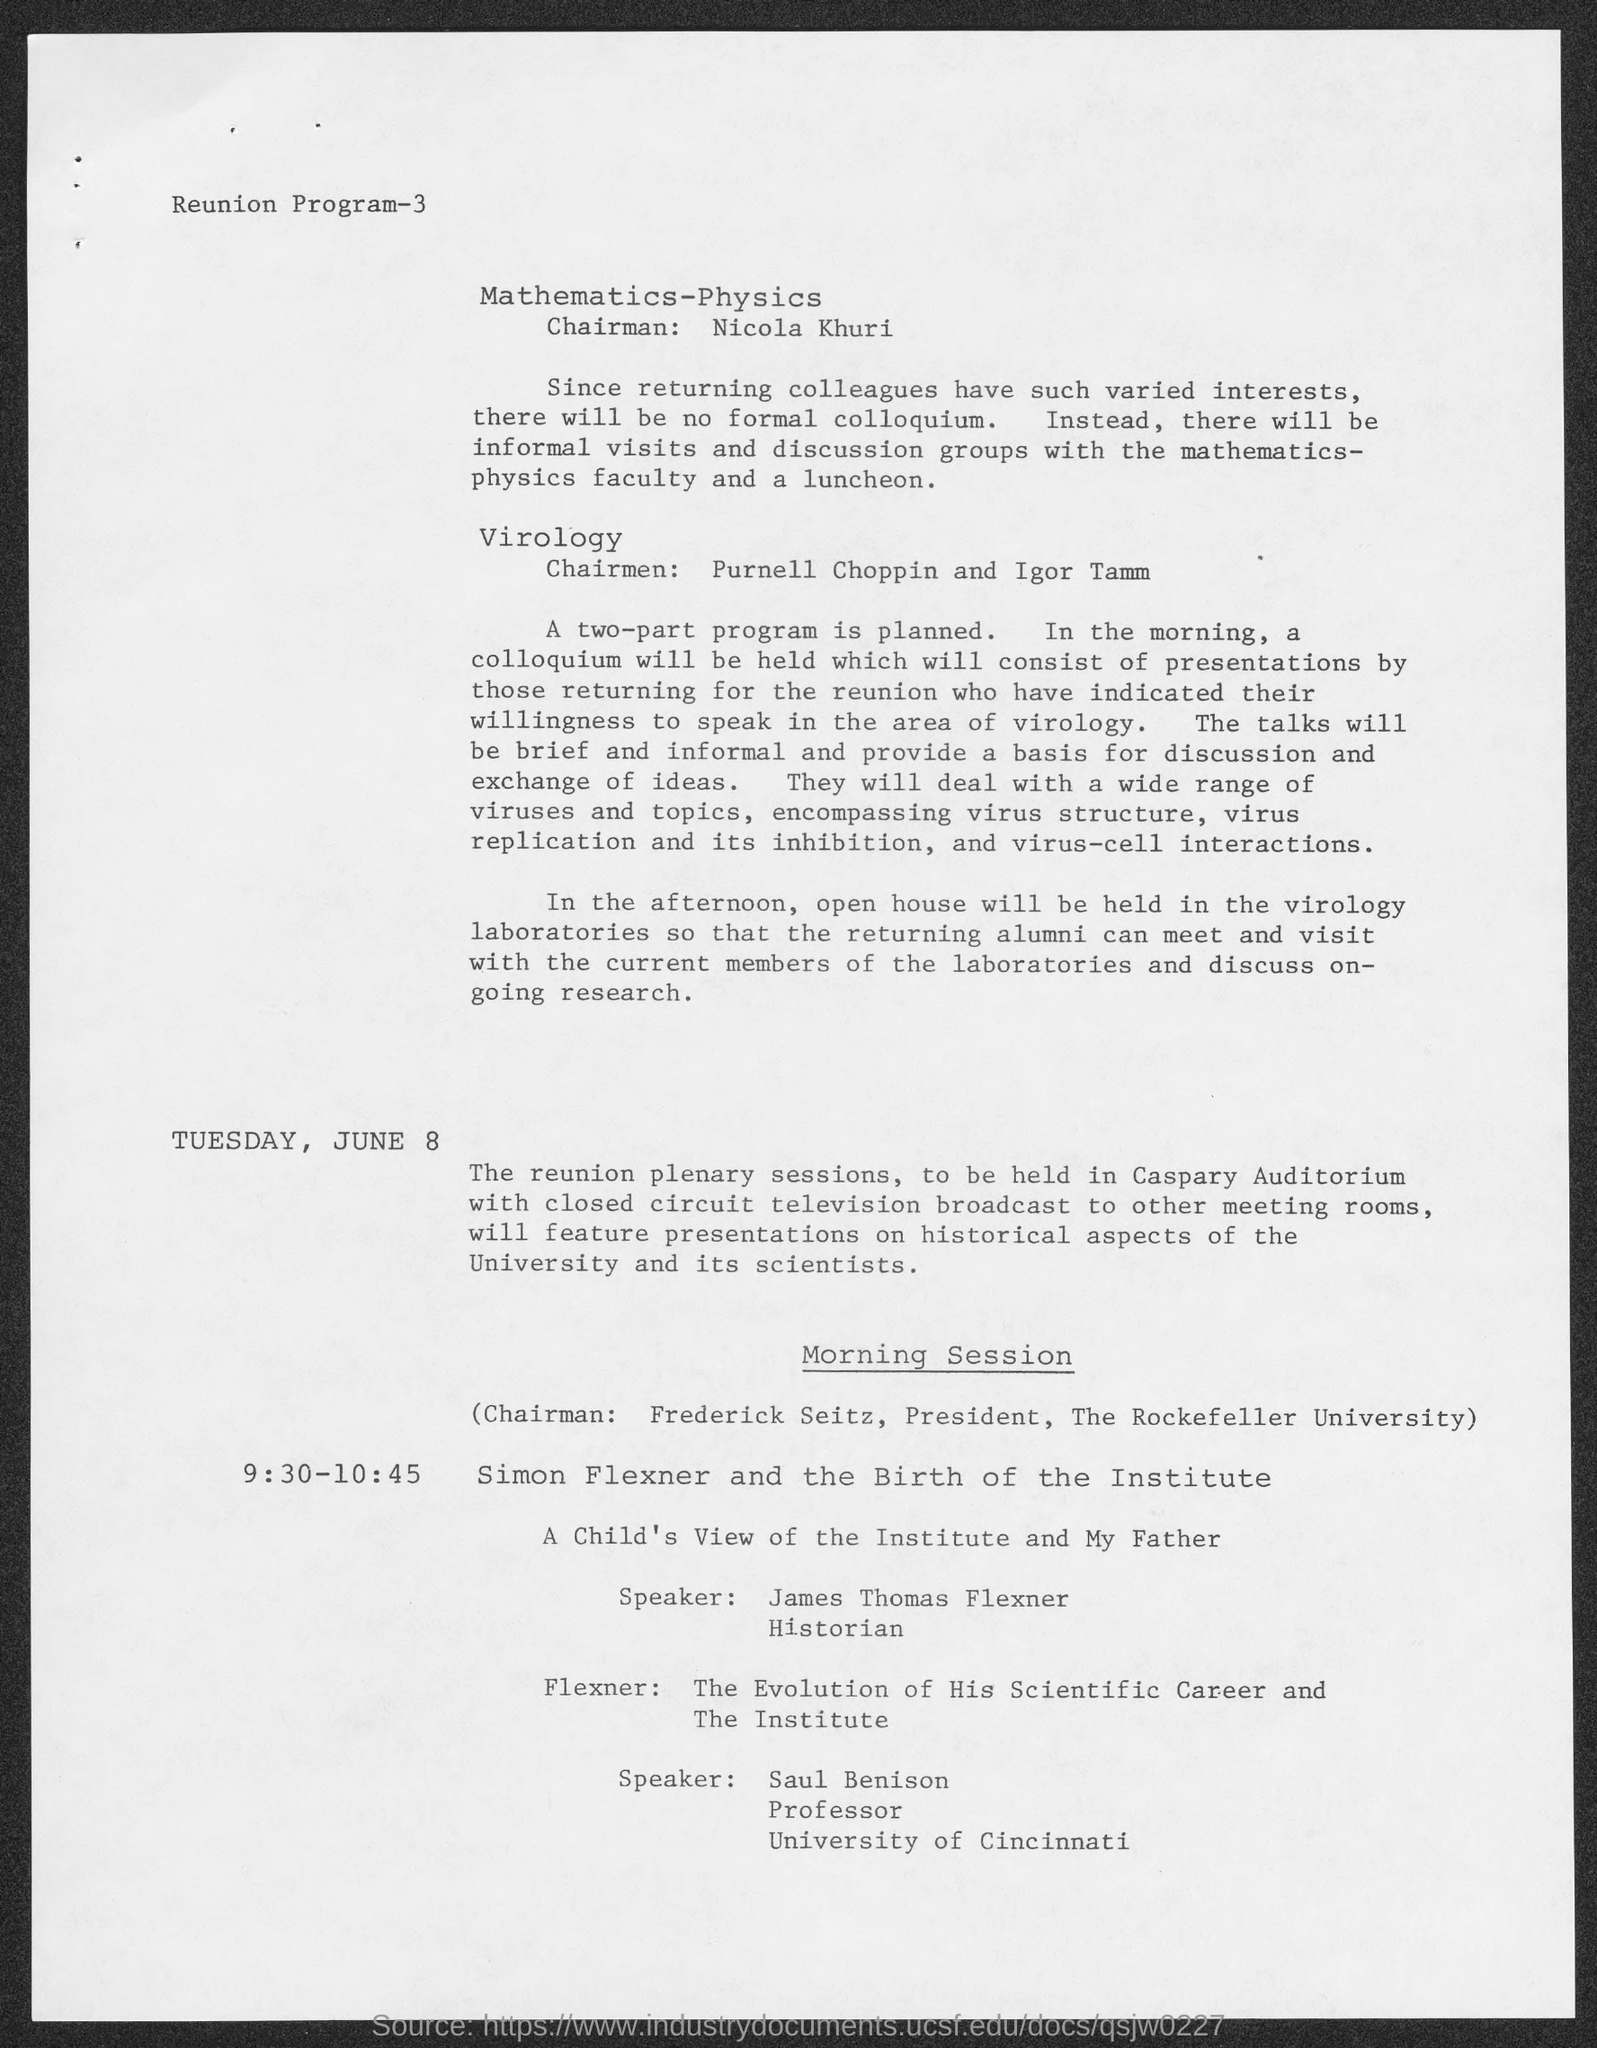Who is the speaker for a child's view of the institute and my father ?
Keep it short and to the point. JAMES THOMAS FLEXNER. To which university does saul benison belong ?
Ensure brevity in your answer.  University of Cincinnati. What is the position of saul benison ?
Your answer should be compact. Professor. Who is the chairman of mathematics- physics?
Offer a very short reply. NICOLA KHURI. Who is the chairman for the morning session?
Keep it short and to the point. FREDERICK SEITZ. To which university does frederick seitz  belong ?
Your response must be concise. The Rockefeller University. 